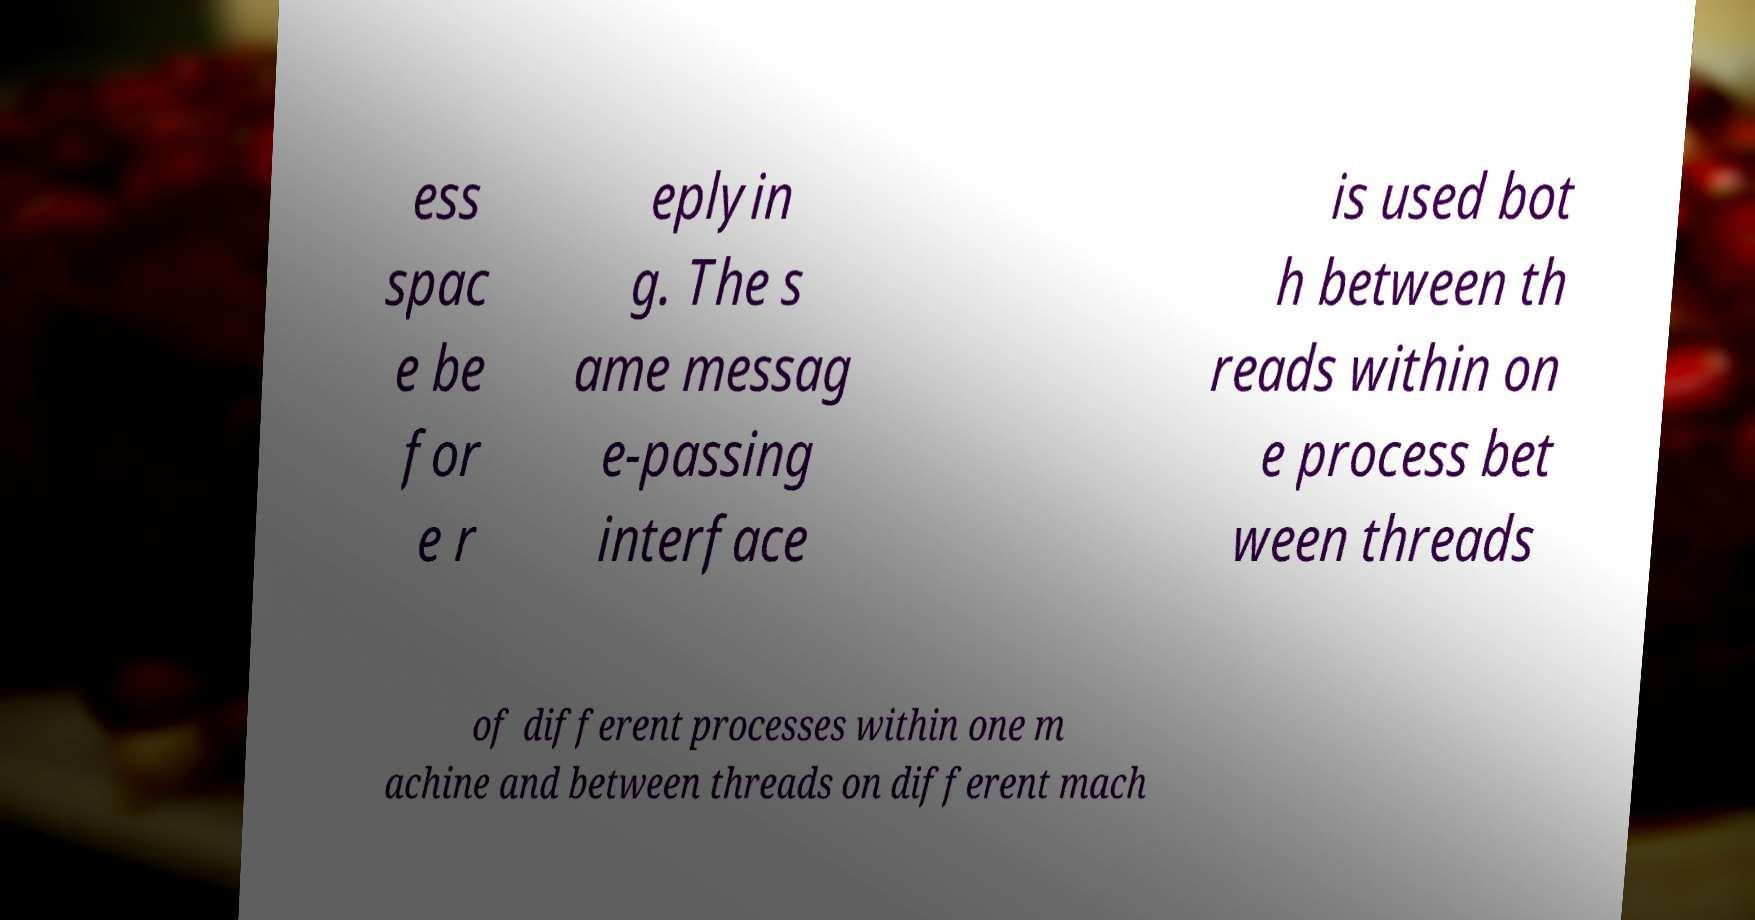Could you extract and type out the text from this image? ess spac e be for e r eplyin g. The s ame messag e-passing interface is used bot h between th reads within on e process bet ween threads of different processes within one m achine and between threads on different mach 